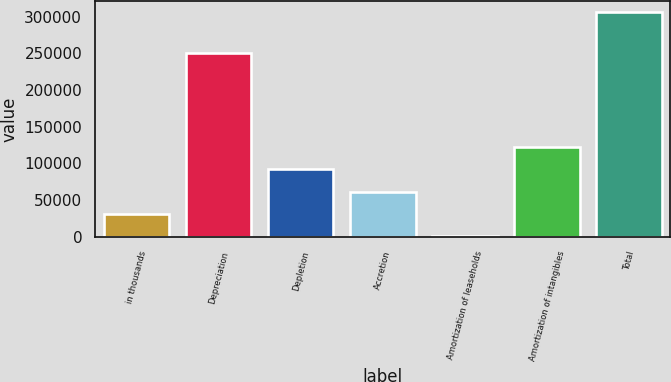<chart> <loc_0><loc_0><loc_500><loc_500><bar_chart><fcel>in thousands<fcel>Depreciation<fcel>Depletion<fcel>Accretion<fcel>Amortization of leaseholds<fcel>Amortization of intangibles<fcel>Total<nl><fcel>31143.7<fcel>250835<fcel>92215.1<fcel>61679.4<fcel>608<fcel>122751<fcel>305965<nl></chart> 